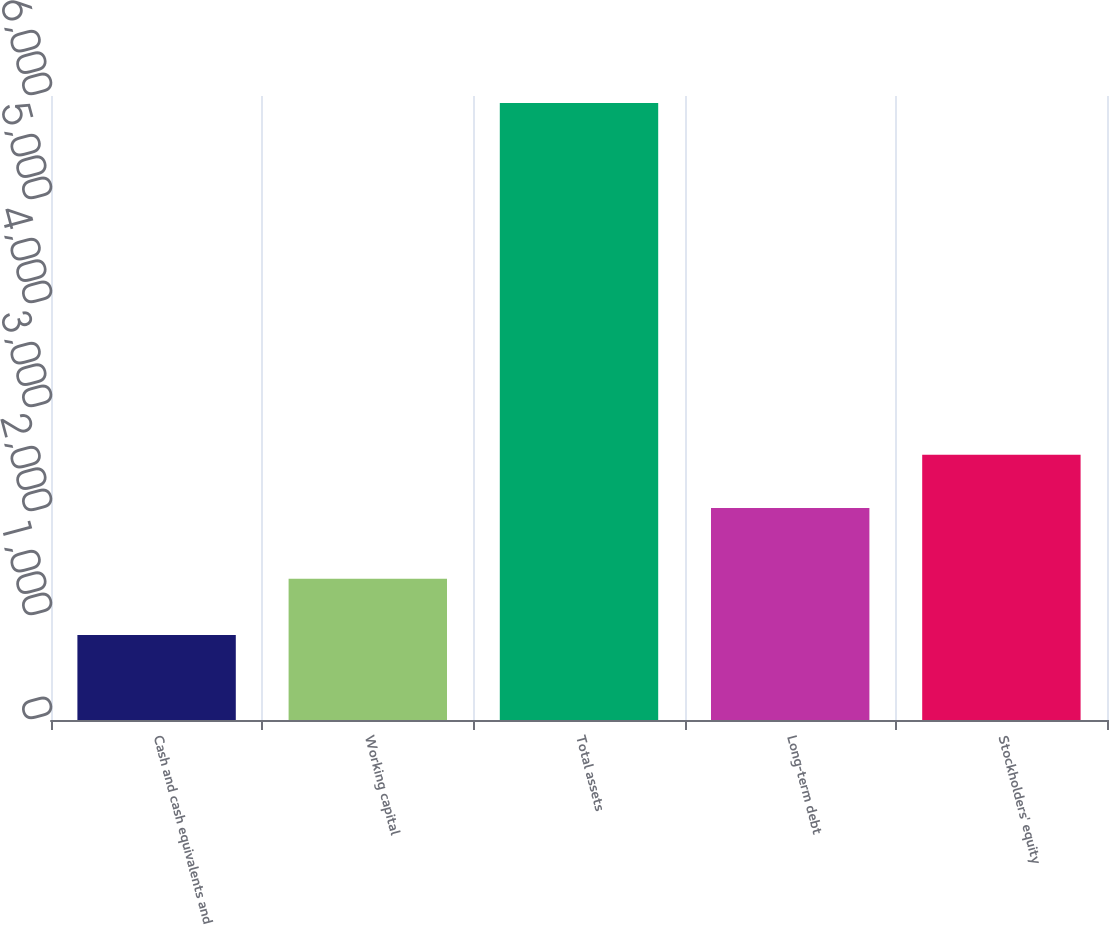Convert chart. <chart><loc_0><loc_0><loc_500><loc_500><bar_chart><fcel>Cash and cash equivalents and<fcel>Working capital<fcel>Total assets<fcel>Long-term debt<fcel>Stockholders' equity<nl><fcel>818<fcel>1358<fcel>5933<fcel>2038<fcel>2549.5<nl></chart> 